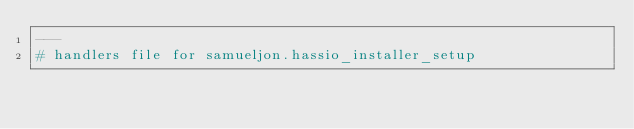<code> <loc_0><loc_0><loc_500><loc_500><_YAML_>---
# handlers file for samueljon.hassio_installer_setup
</code> 